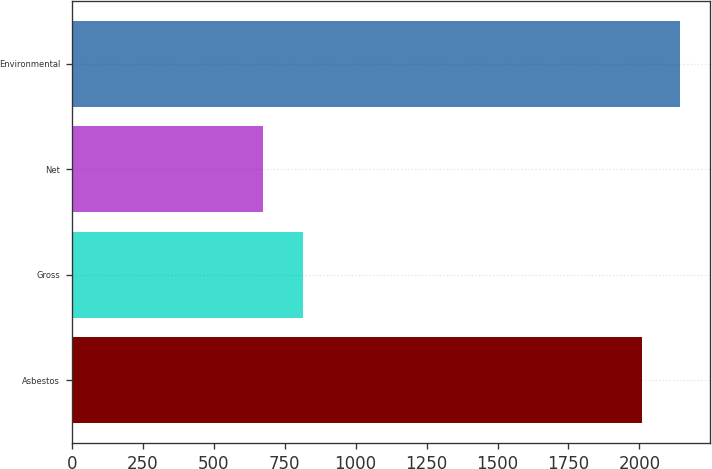Convert chart. <chart><loc_0><loc_0><loc_500><loc_500><bar_chart><fcel>Asbestos<fcel>Gross<fcel>Net<fcel>Environmental<nl><fcel>2008<fcel>813<fcel>675<fcel>2141.3<nl></chart> 